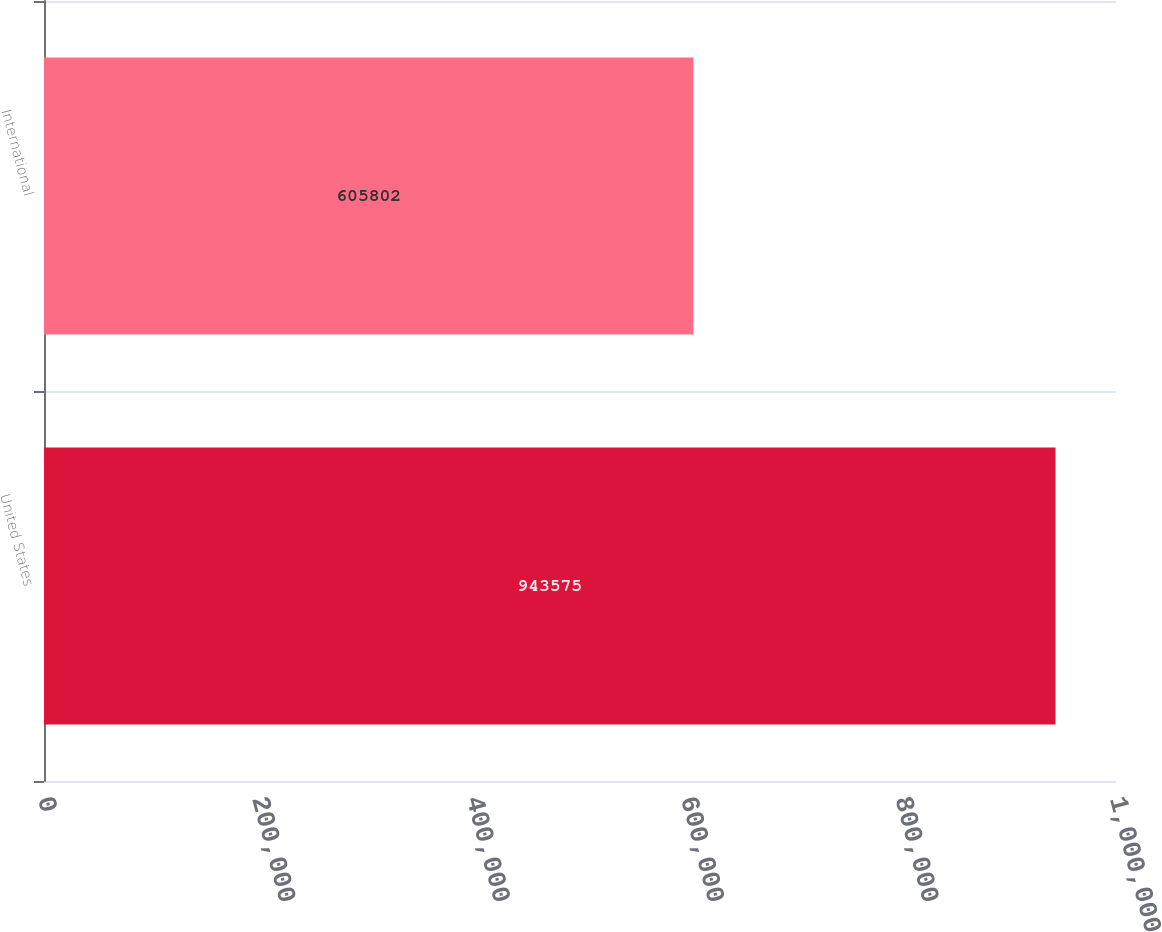<chart> <loc_0><loc_0><loc_500><loc_500><bar_chart><fcel>United States<fcel>International<nl><fcel>943575<fcel>605802<nl></chart> 